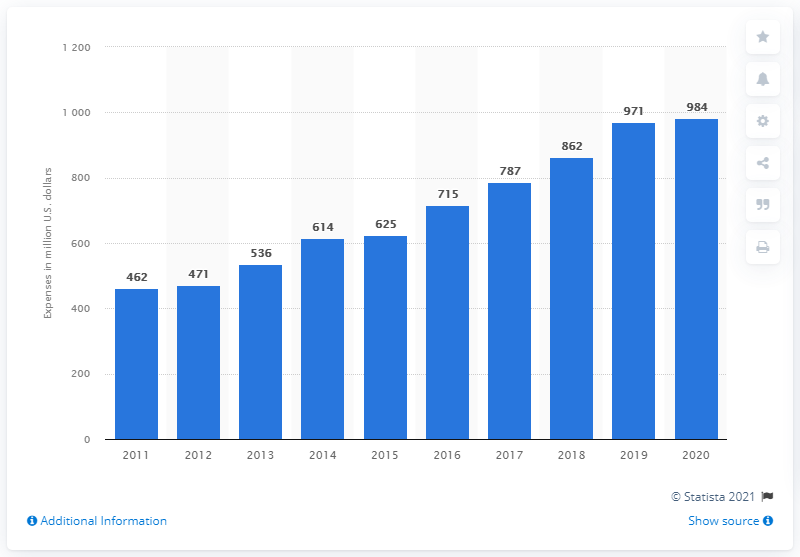Can you provide a comparison between the expenditure in 2015 versus 2020? Certainly, in 2015, Stryker allocated 715 million U.S. dollars to research, development, and engineering. By 2020, this figure had increased by 269 million dollars to a total of 984 million dollars, showing a substantial rise of approximately 37.6% over the five-year span, highlighting a robust approach to R&D investment. 